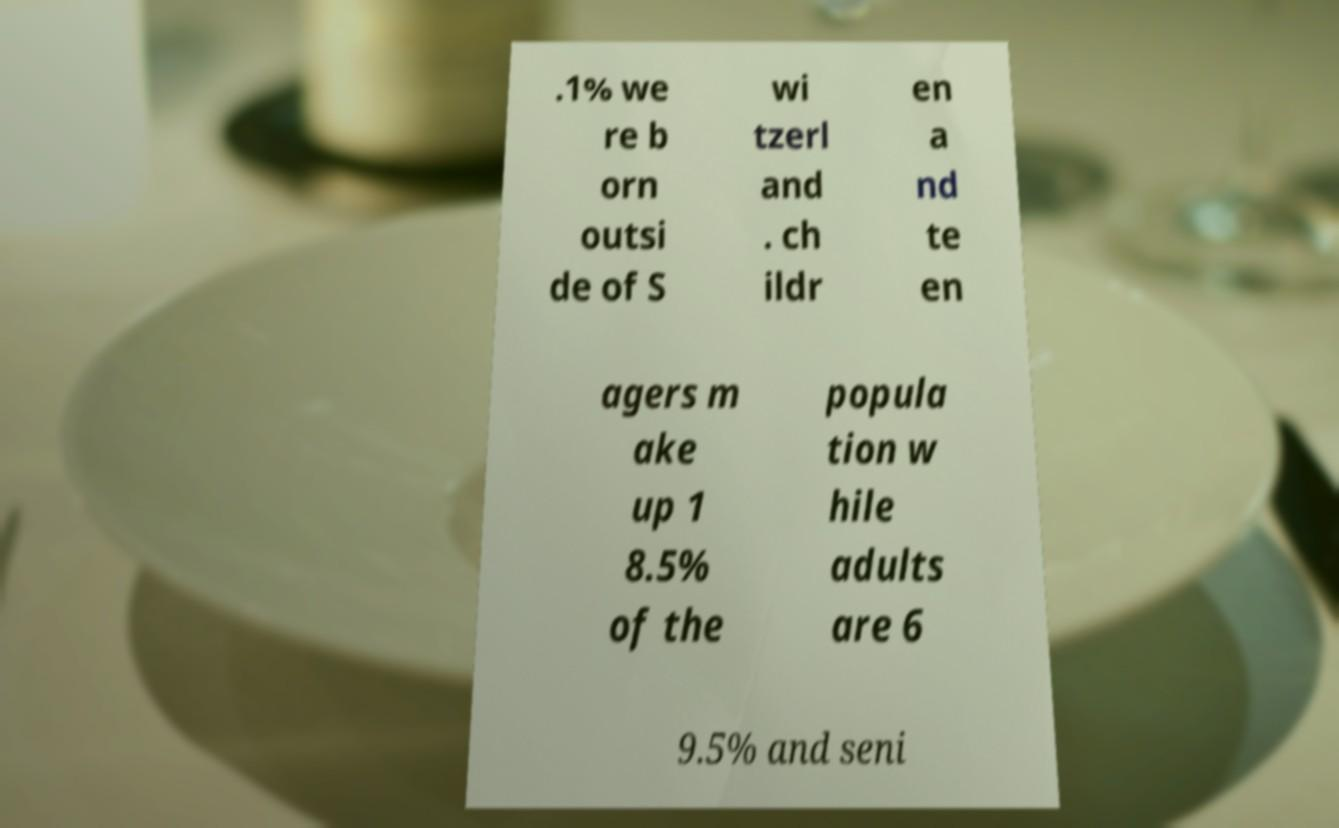Could you extract and type out the text from this image? .1% we re b orn outsi de of S wi tzerl and . ch ildr en a nd te en agers m ake up 1 8.5% of the popula tion w hile adults are 6 9.5% and seni 